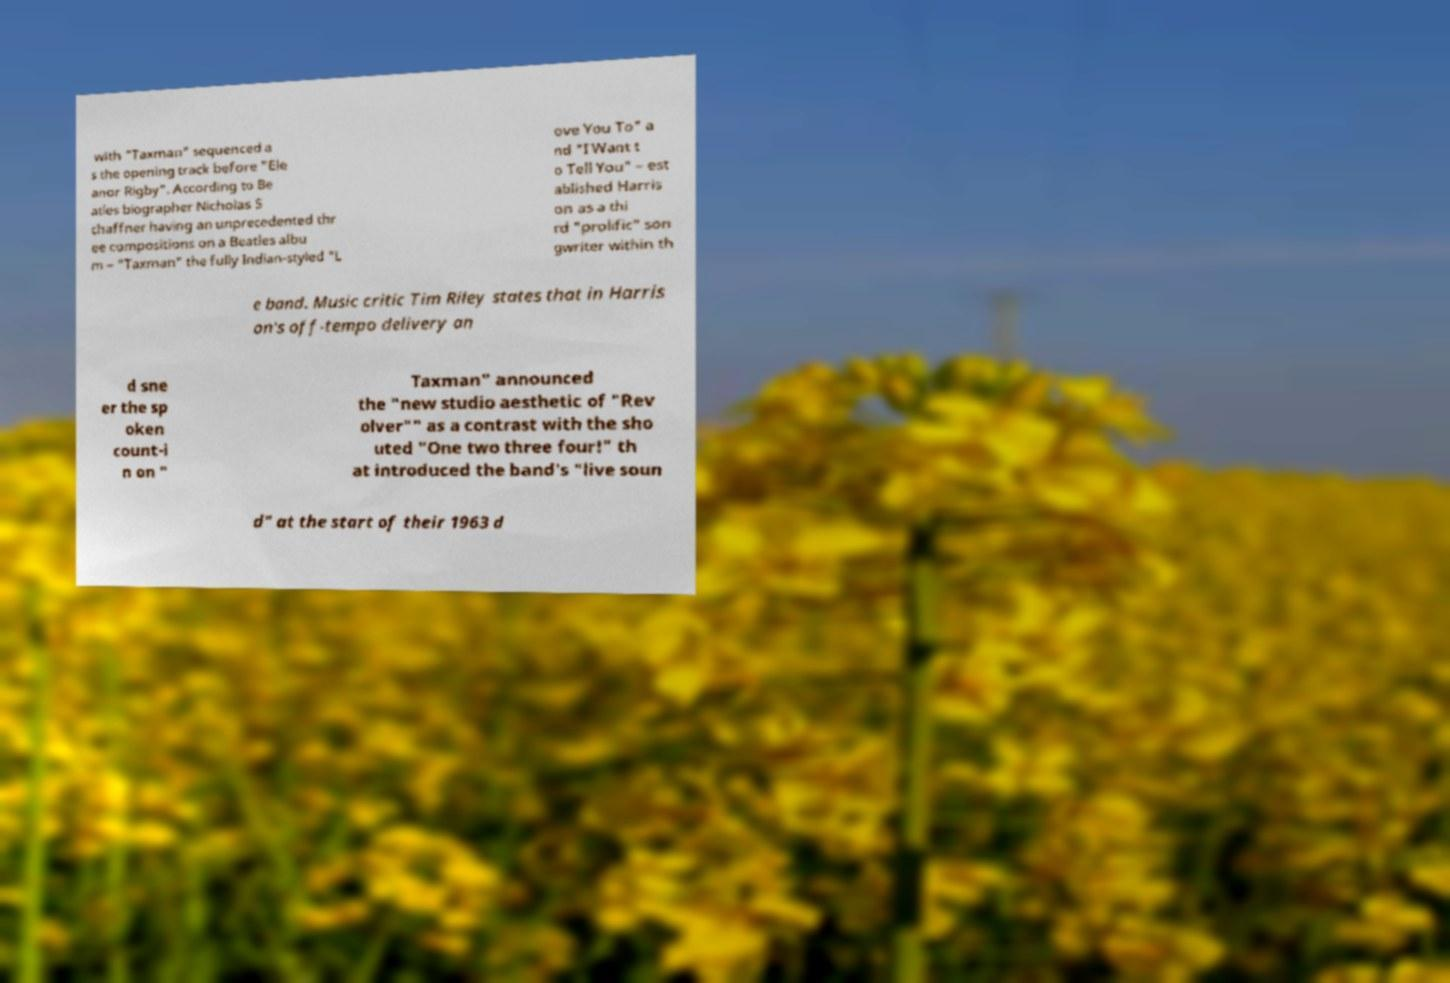Can you accurately transcribe the text from the provided image for me? with "Taxman" sequenced a s the opening track before "Ele anor Rigby". According to Be atles biographer Nicholas S chaffner having an unprecedented thr ee compositions on a Beatles albu m – "Taxman" the fully Indian-styled "L ove You To" a nd "I Want t o Tell You" – est ablished Harris on as a thi rd "prolific" son gwriter within th e band. Music critic Tim Riley states that in Harris on's off-tempo delivery an d sne er the sp oken count-i n on " Taxman" announced the "new studio aesthetic of "Rev olver"" as a contrast with the sho uted "One two three four!" th at introduced the band's "live soun d" at the start of their 1963 d 